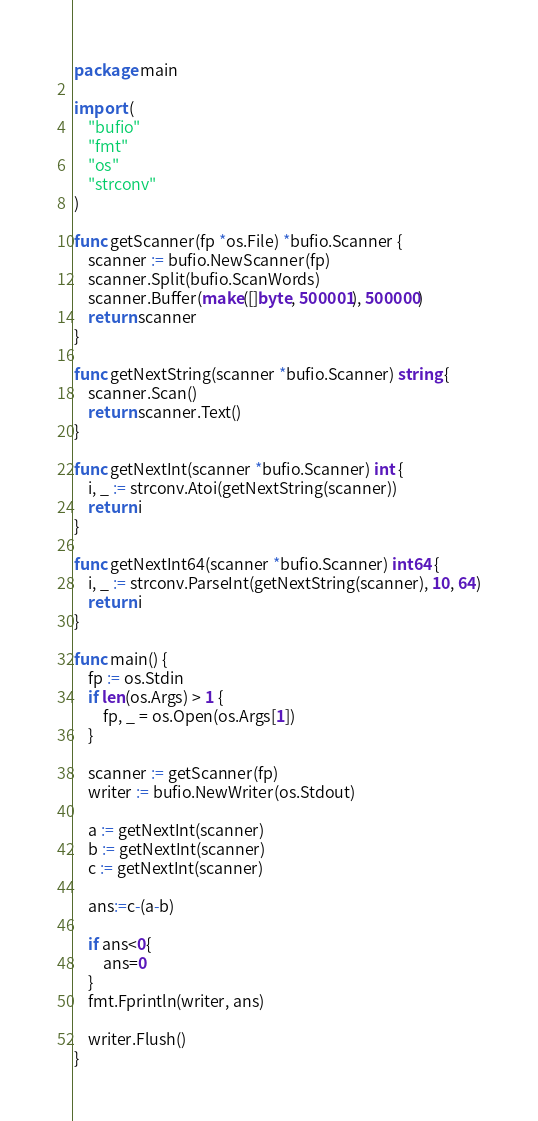Convert code to text. <code><loc_0><loc_0><loc_500><loc_500><_Go_>package main

import (
	"bufio"
	"fmt"
	"os"
	"strconv"
)

func getScanner(fp *os.File) *bufio.Scanner {
	scanner := bufio.NewScanner(fp)
	scanner.Split(bufio.ScanWords)
	scanner.Buffer(make([]byte, 500001), 500000)
	return scanner
}

func getNextString(scanner *bufio.Scanner) string {
	scanner.Scan()
	return scanner.Text()
}

func getNextInt(scanner *bufio.Scanner) int {
	i, _ := strconv.Atoi(getNextString(scanner))
	return i
}

func getNextInt64(scanner *bufio.Scanner) int64 {
	i, _ := strconv.ParseInt(getNextString(scanner), 10, 64)
	return i
}

func main() {
	fp := os.Stdin
	if len(os.Args) > 1 {
		fp, _ = os.Open(os.Args[1])
	}

	scanner := getScanner(fp)
	writer := bufio.NewWriter(os.Stdout)

	a := getNextInt(scanner)
	b := getNextInt(scanner)
	c := getNextInt(scanner)

	ans:=c-(a-b)

	if ans<0{
		ans=0
	}
	fmt.Fprintln(writer, ans)

	writer.Flush()
}
</code> 